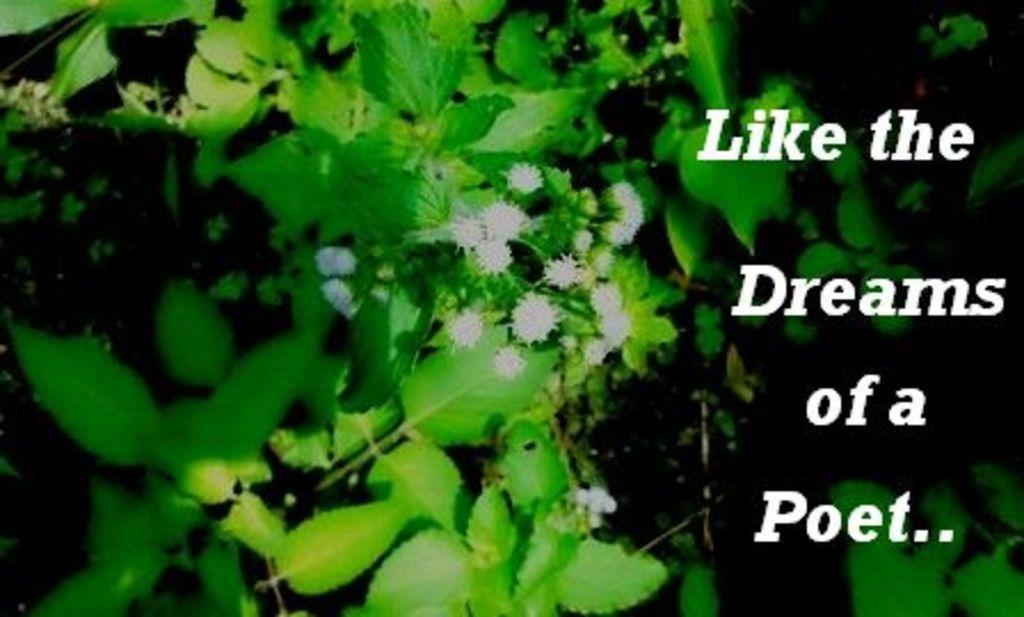What type of living organisms are present in the image? There are plants in the image. What color are the leaves of the plants? The leaves of the plants have a green color. Are there any flowers visible in the image? Yes, there appear to be white flowers in the image. What can be found on the right side of the image? There is text on the right side of the image. What type of juice is being served to the passenger in the image? There is no reference to juice or a passenger in the image, so it is not possible to answer that question. 